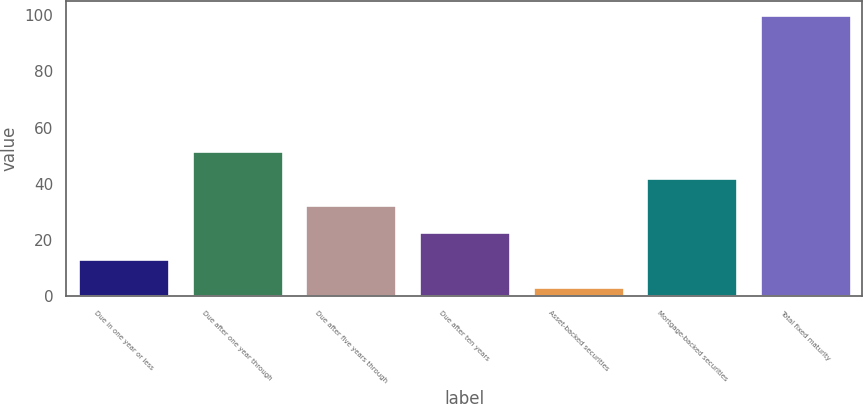Convert chart. <chart><loc_0><loc_0><loc_500><loc_500><bar_chart><fcel>Due in one year or less<fcel>Due after one year through<fcel>Due after five years through<fcel>Due after ten years<fcel>Asset-backed securities<fcel>Mortgage-backed securities<fcel>Total fixed maturity<nl><fcel>13.15<fcel>51.75<fcel>32.45<fcel>22.8<fcel>3.5<fcel>42.1<fcel>100<nl></chart> 